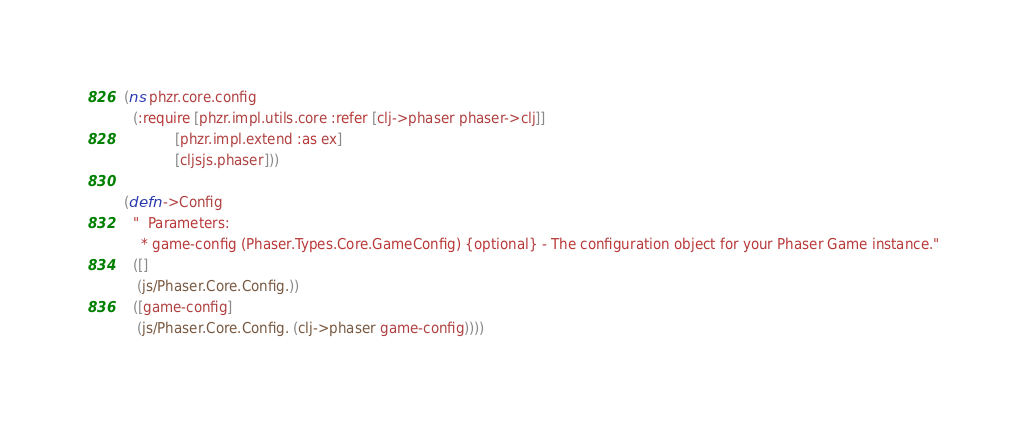<code> <loc_0><loc_0><loc_500><loc_500><_Clojure_>(ns phzr.core.config
  (:require [phzr.impl.utils.core :refer [clj->phaser phaser->clj]]
            [phzr.impl.extend :as ex]
            [cljsjs.phaser]))

(defn ->Config
  "  Parameters:
    * game-config (Phaser.Types.Core.GameConfig) {optional} - The configuration object for your Phaser Game instance."
  ([]
   (js/Phaser.Core.Config.))
  ([game-config]
   (js/Phaser.Core.Config. (clj->phaser game-config))))

</code> 